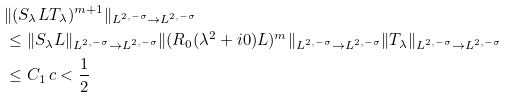<formula> <loc_0><loc_0><loc_500><loc_500>& \| ( S _ { \lambda } L T _ { \lambda } ) ^ { m + 1 } \| _ { L ^ { 2 , - \sigma } \to L ^ { 2 , - \sigma } } \\ & \leq \| S _ { \lambda } L \| _ { L ^ { 2 , - \sigma } \to L ^ { 2 , - \sigma } } \| ( R _ { 0 } ( \lambda ^ { 2 } + i 0 ) L ) ^ { m } \| _ { L ^ { 2 , - \sigma } \to L ^ { 2 , - \sigma } } \| T _ { \lambda } \| _ { L ^ { 2 , - \sigma } \to L ^ { 2 , - \sigma } } \\ & \leq C _ { 1 } \, c < \frac { 1 } { 2 }</formula> 